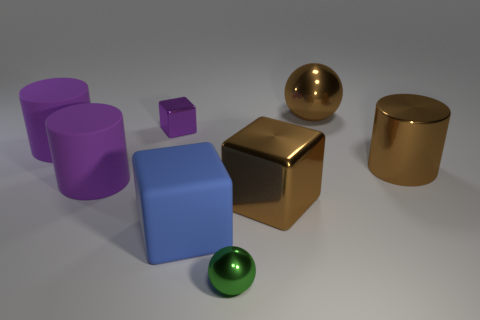Do the blue block and the brown metallic block have the same size?
Offer a terse response. Yes. How big is the block that is both behind the blue matte block and in front of the small purple block?
Give a very brief answer. Large. What number of rubber objects are either big brown spheres or brown blocks?
Ensure brevity in your answer.  0. Is the number of large matte things that are in front of the big brown cube greater than the number of big cyan shiny objects?
Ensure brevity in your answer.  Yes. What is the material of the big cylinder on the right side of the brown metal block?
Your answer should be compact. Metal. What number of small purple blocks have the same material as the green object?
Your answer should be compact. 1. There is a large thing that is both behind the big metal cylinder and in front of the large metallic ball; what shape is it?
Provide a succinct answer. Cylinder. What number of things are big cylinders on the left side of the rubber cube or rubber objects that are right of the purple block?
Provide a short and direct response. 3. Is the number of tiny balls that are behind the small block the same as the number of things in front of the green metal thing?
Your answer should be very brief. Yes. There is a large brown thing behind the small purple metallic cube in front of the big metallic ball; what shape is it?
Make the answer very short. Sphere. 